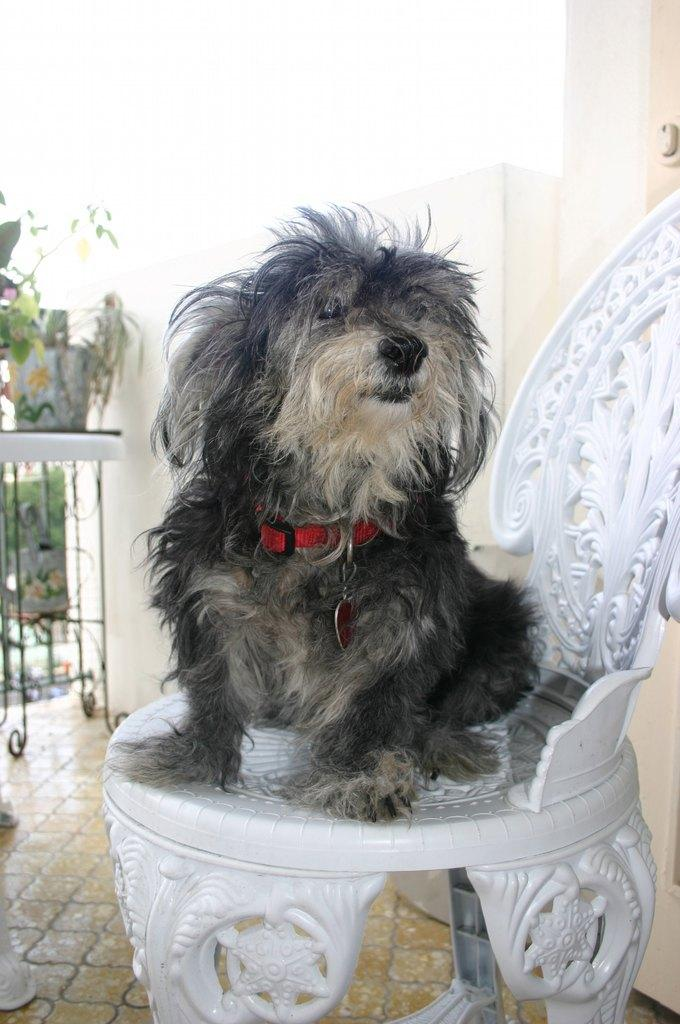What type of creature is in the image? There is an animal in the image. Where is the animal located in the image? The animal is sitting on a chair. What else can be seen in the image besides the animal? There is a plant pot on a table in the image. Can you tell me how many children are talking to the animal in the image? There are no children present in the image, and the animal is not depicted as engaging in any conversation. 